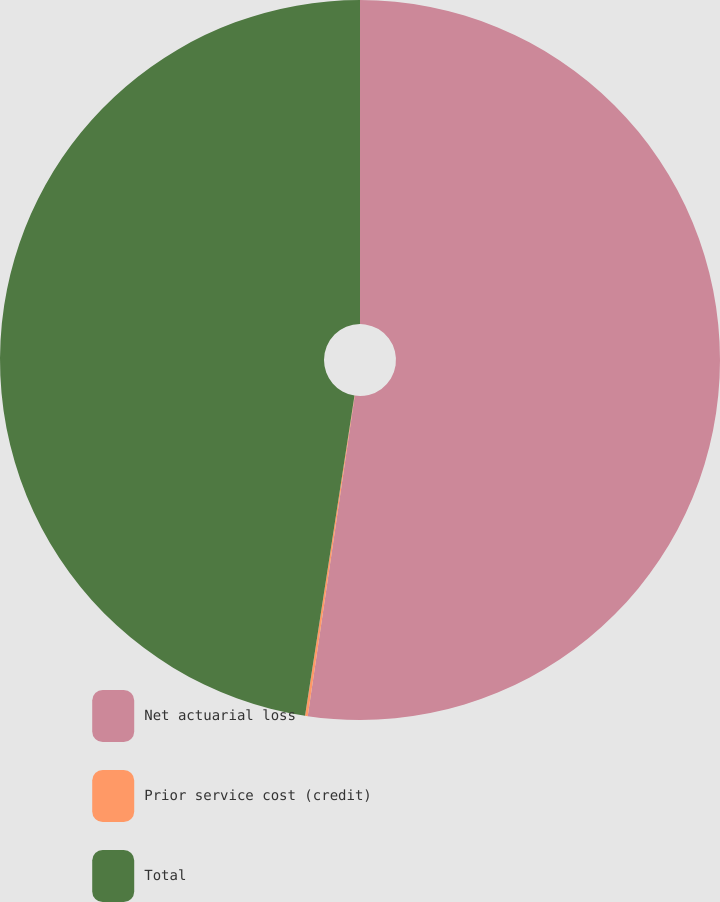<chart> <loc_0><loc_0><loc_500><loc_500><pie_chart><fcel>Net actuarial loss<fcel>Prior service cost (credit)<fcel>Total<nl><fcel>52.32%<fcel>0.12%<fcel>47.56%<nl></chart> 